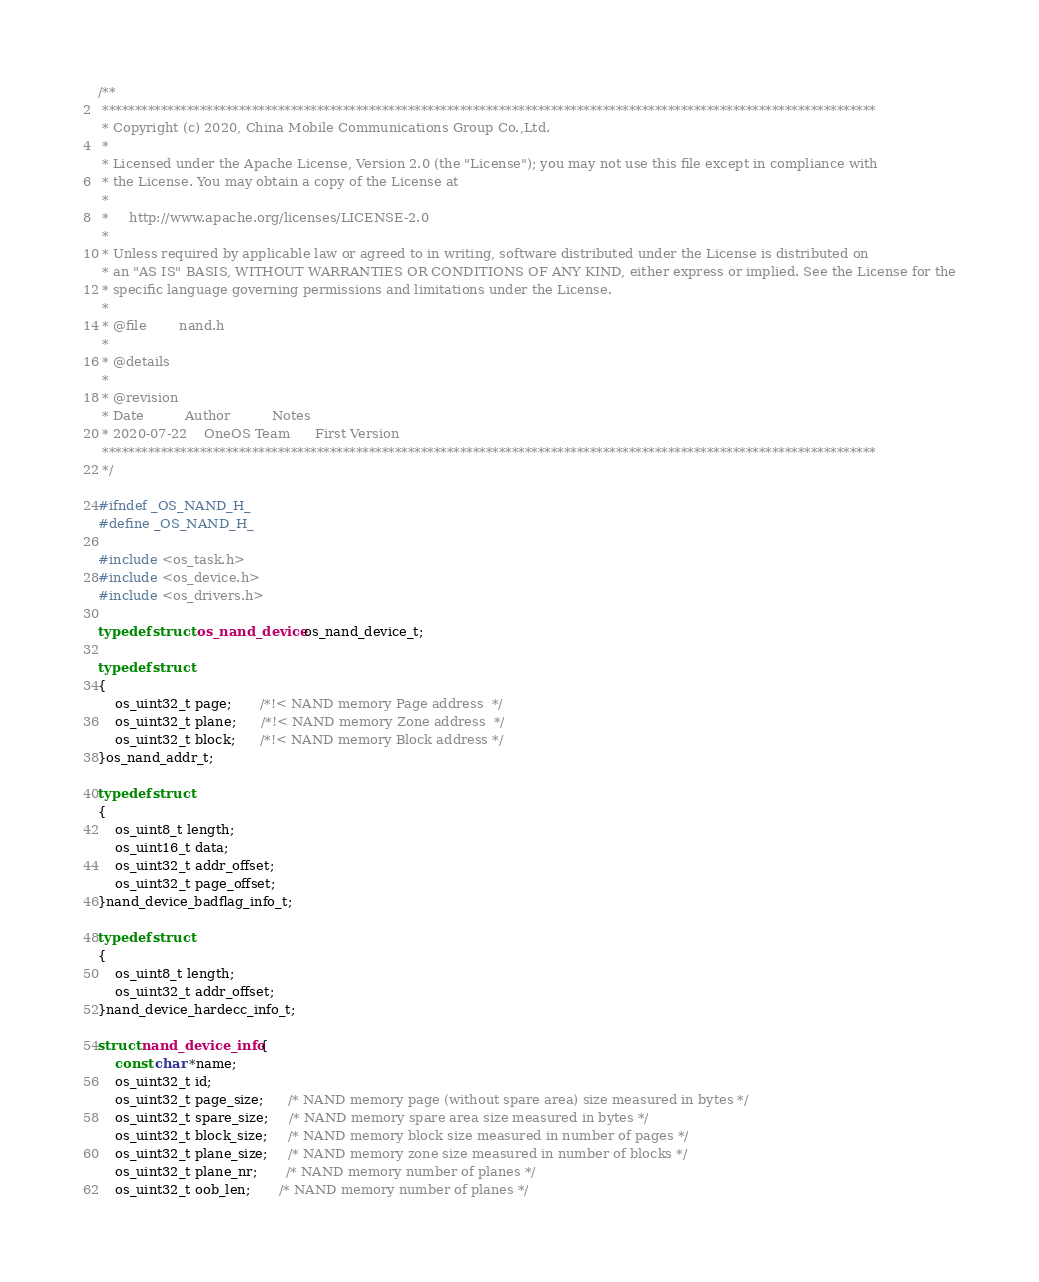Convert code to text. <code><loc_0><loc_0><loc_500><loc_500><_C_>/**
 ***********************************************************************************************************************
 * Copyright (c) 2020, China Mobile Communications Group Co.,Ltd.
 *
 * Licensed under the Apache License, Version 2.0 (the "License"); you may not use this file except in compliance with 
 * the License. You may obtain a copy of the License at
 *
 *     http://www.apache.org/licenses/LICENSE-2.0
 *
 * Unless required by applicable law or agreed to in writing, software distributed under the License is distributed on
 * an "AS IS" BASIS, WITHOUT WARRANTIES OR CONDITIONS OF ANY KIND, either express or implied. See the License for the
 * specific language governing permissions and limitations under the License.
 *
 * @file        nand.h
 *
 * @details
 *
 * @revision
 * Date          Author          Notes
 * 2020-07-22    OneOS Team      First Version
 ***********************************************************************************************************************
 */

#ifndef _OS_NAND_H_
#define _OS_NAND_H_

#include <os_task.h>
#include <os_device.h>
#include <os_drivers.h>

typedef struct os_nand_device os_nand_device_t;

typedef struct
{
    os_uint32_t page;       /*!< NAND memory Page address  */
    os_uint32_t plane;      /*!< NAND memory Zone address  */
    os_uint32_t block;      /*!< NAND memory Block address */
}os_nand_addr_t;

typedef struct
{
    os_uint8_t length;
    os_uint16_t data;
    os_uint32_t addr_offset;
    os_uint32_t page_offset;
}nand_device_badflag_info_t;

typedef struct
{
    os_uint8_t length;
    os_uint32_t addr_offset;
}nand_device_hardecc_info_t;

struct nand_device_info {
    const char *name;
    os_uint32_t id;
    os_uint32_t page_size;      /* NAND memory page (without spare area) size measured in bytes */
    os_uint32_t spare_size;     /* NAND memory spare area size measured in bytes */
    os_uint32_t block_size;     /* NAND memory block size measured in number of pages */
    os_uint32_t plane_size;     /* NAND memory zone size measured in number of blocks */
    os_uint32_t plane_nr;       /* NAND memory number of planes */
    os_uint32_t oob_len;       /* NAND memory number of planes */</code> 